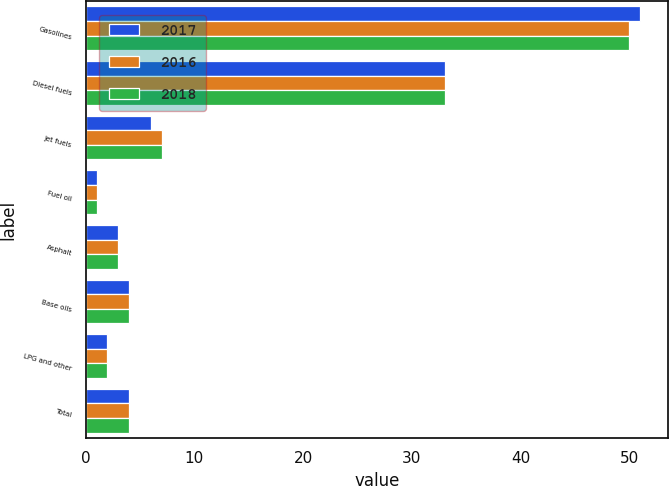Convert chart to OTSL. <chart><loc_0><loc_0><loc_500><loc_500><stacked_bar_chart><ecel><fcel>Gasolines<fcel>Diesel fuels<fcel>Jet fuels<fcel>Fuel oil<fcel>Asphalt<fcel>Base oils<fcel>LPG and other<fcel>Total<nl><fcel>2017<fcel>51<fcel>33<fcel>6<fcel>1<fcel>3<fcel>4<fcel>2<fcel>4<nl><fcel>2016<fcel>50<fcel>33<fcel>7<fcel>1<fcel>3<fcel>4<fcel>2<fcel>4<nl><fcel>2018<fcel>50<fcel>33<fcel>7<fcel>1<fcel>3<fcel>4<fcel>2<fcel>4<nl></chart> 